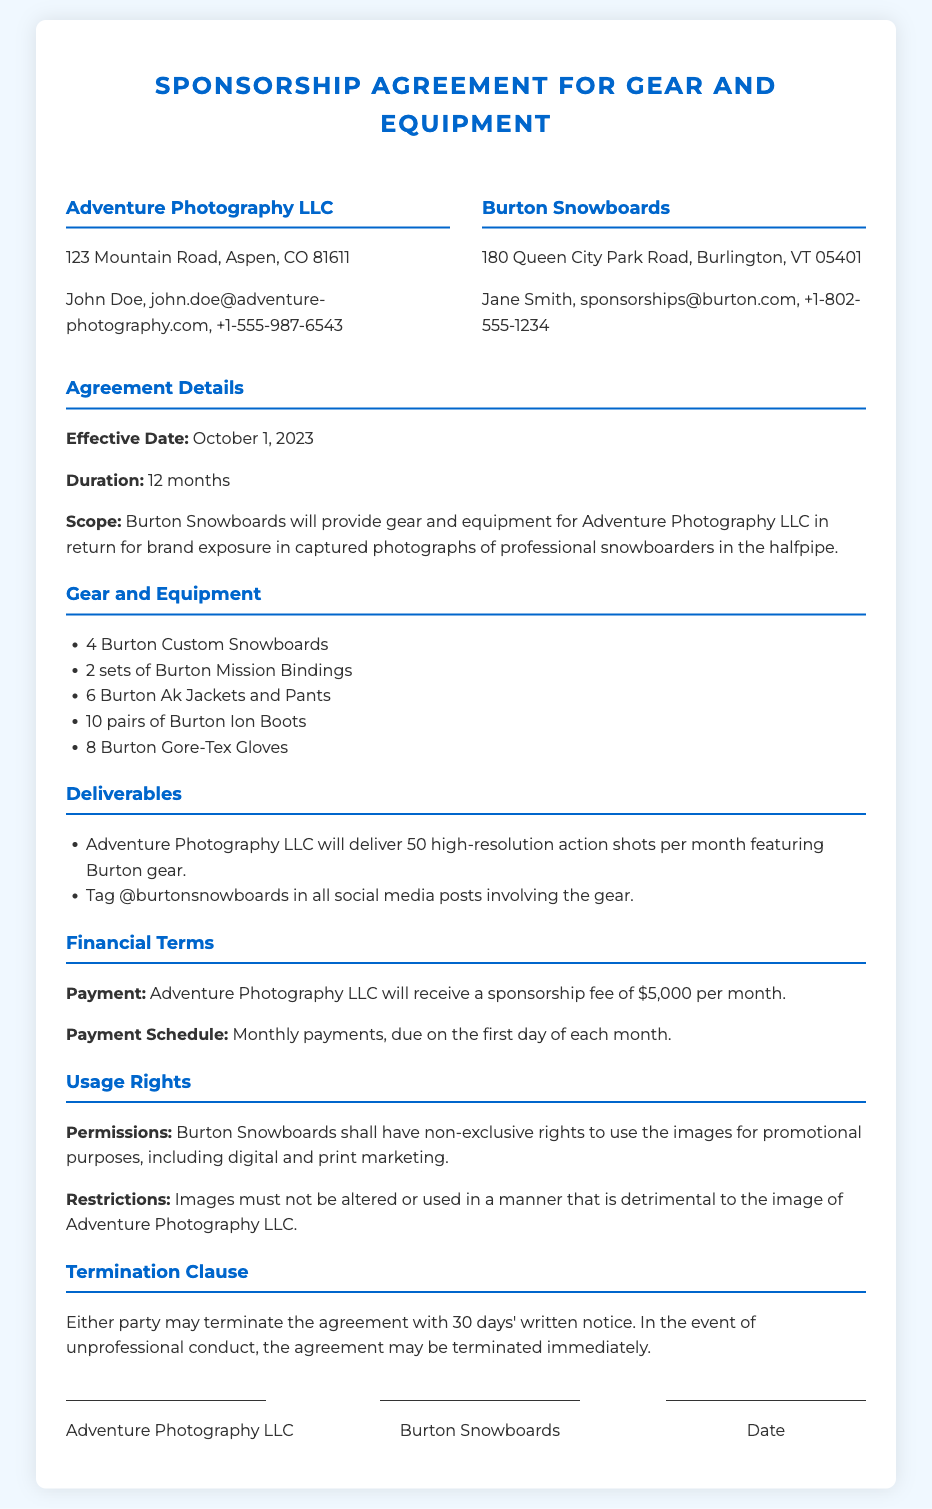What is the effective date of the agreement? The effective date is explicitly stated in the document as the start of the agreement period.
Answer: October 1, 2023 How long is the duration of the sponsorship? The duration is mentioned clearly in the document as part of the agreement terms.
Answer: 12 months Who is the contact person for Adventure Photography LLC? The contact person is listed under the party information section of the document.
Answer: John Doe What is the monthly sponsorship fee? The payment terms section specifies the fee to be received monthly.
Answer: $5,000 How many high-resolution action shots must be delivered each month? The deliverables section outlines the quantity of shots required from Adventure Photography LLC.
Answer: 50 What is the total number of Burton Custom Snowboards provided? The gear and equipment list explicitly states how many of a specific item is included.
Answer: 4 What rights does Burton Snowboards have regarding the images? The usage rights section describes the permissions granted for the use of images.
Answer: Non-exclusive rights What is the notice period for termination of the agreement? The termination clause specifies the notice period in days.
Answer: 30 days Under what condition can the agreement be terminated immediately? The termination clause outlines specific situations that warrant immediate termination.
Answer: Unprofessional conduct 